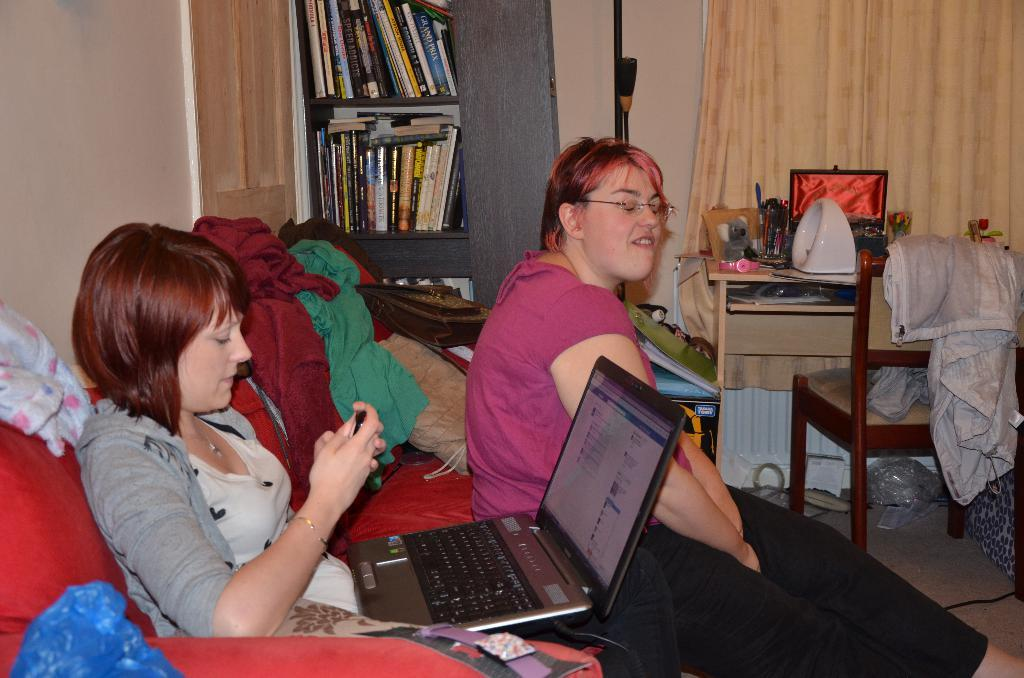How many people are in the room? There are 2 people in the room. What electronic device can be seen in the room? There is a laptop in the room. What items are present in the room that might be used for clothing? There are clothes in the room. What type of storage is available for books in the room? There are books on shelves in the room. What furniture is present in the room for sitting or working? There is a table and a chair in the room. What type of window treatment is present in the room? There are curtains at the back of the room. What type of powder is being used to season the celery in the room? There is no celery or powder present in the room; the image only shows a laptop, clothes, books on shelves, a table, a chair, and curtains. 